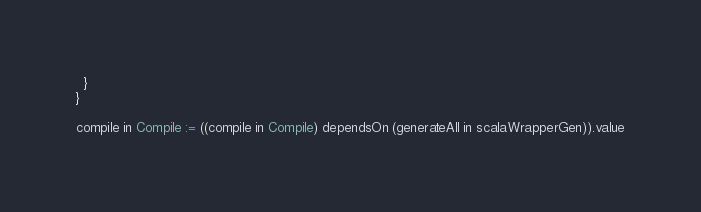Convert code to text. <code><loc_0><loc_0><loc_500><loc_500><_Scala_>  }
}

compile in Compile := ((compile in Compile) dependsOn (generateAll in scalaWrapperGen)).value
</code> 